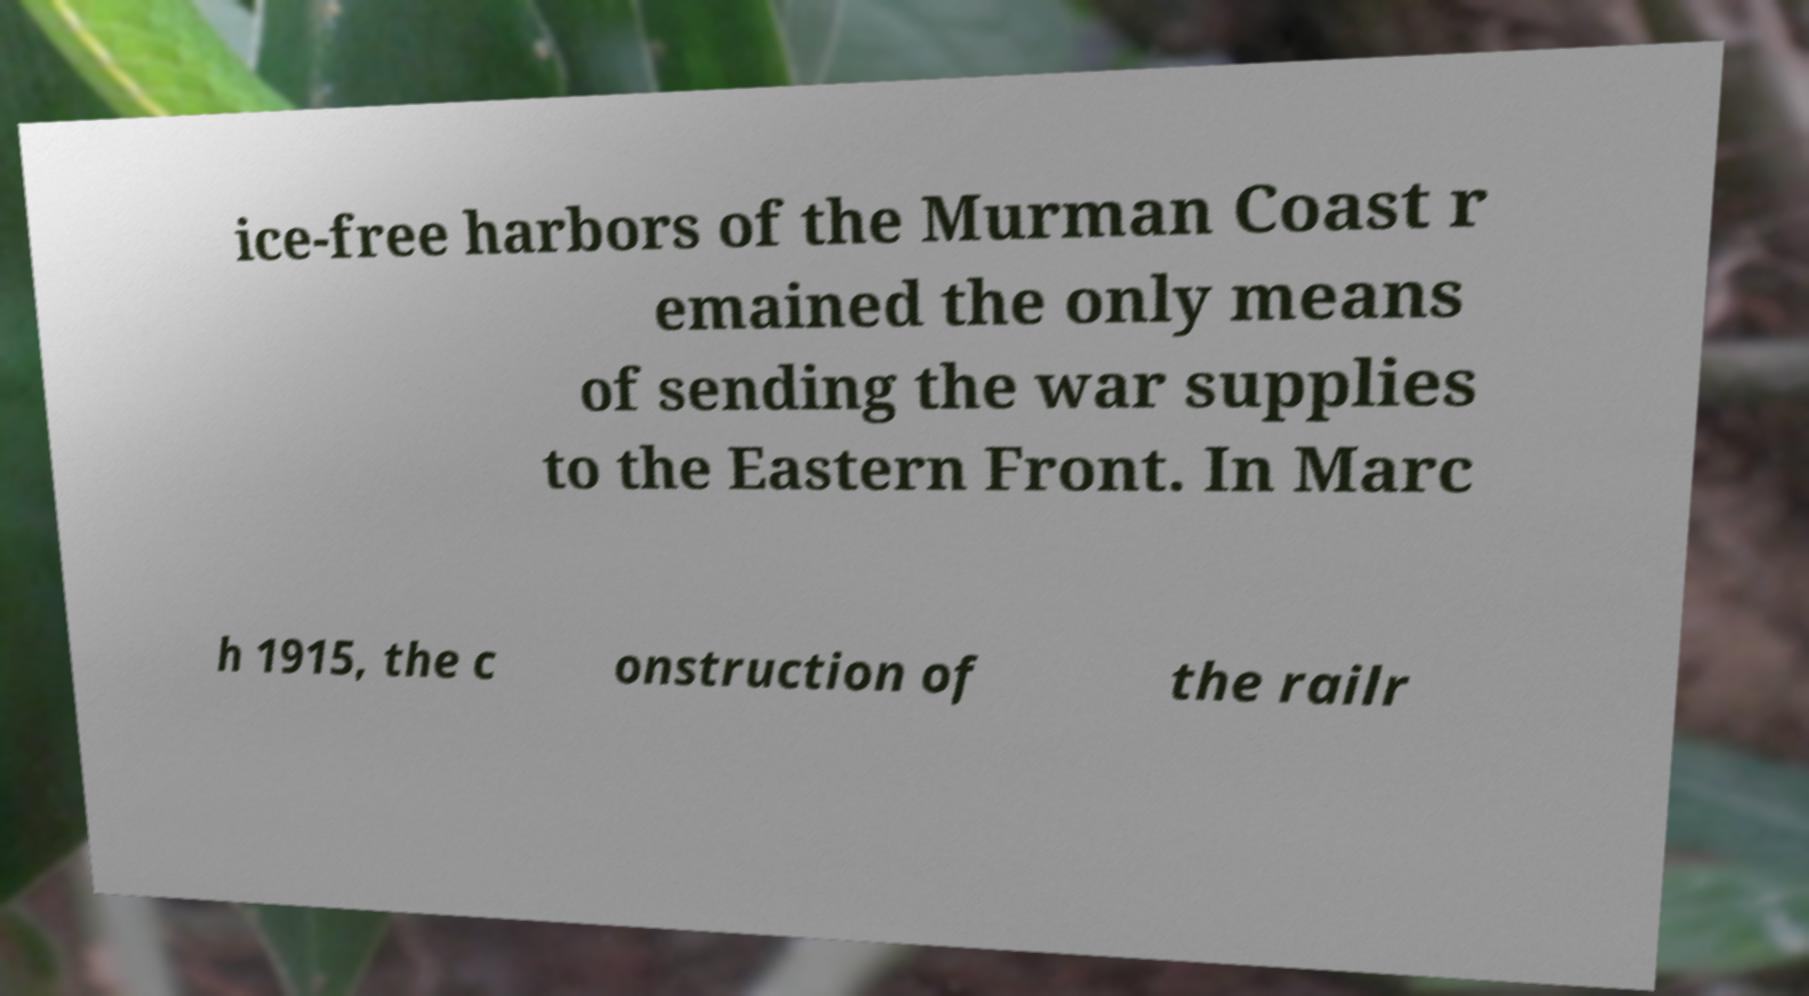Please read and relay the text visible in this image. What does it say? ice-free harbors of the Murman Coast r emained the only means of sending the war supplies to the Eastern Front. In Marc h 1915, the c onstruction of the railr 